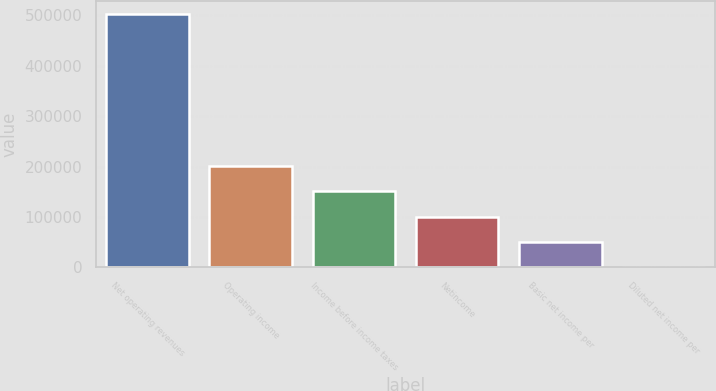<chart> <loc_0><loc_0><loc_500><loc_500><bar_chart><fcel>Net operating revenues<fcel>Operating income<fcel>Income before income taxes<fcel>Netincome<fcel>Basic net income per<fcel>Diluted net income per<nl><fcel>503096<fcel>201239<fcel>150929<fcel>100620<fcel>50310.3<fcel>0.81<nl></chart> 